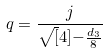<formula> <loc_0><loc_0><loc_500><loc_500>q = \frac { j } { \sqrt { [ } 4 ] { - \frac { d _ { 3 } } { 8 } } }</formula> 